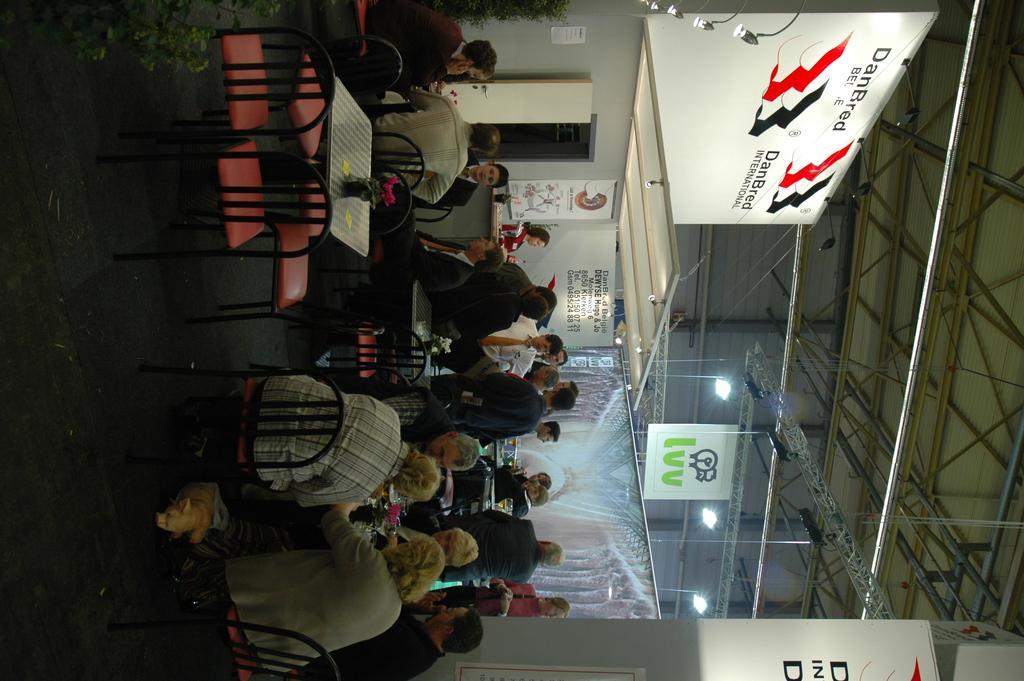Can you describe this image briefly? As we can see in the image there are few people here and there, chairs, tables, wall and banners. 